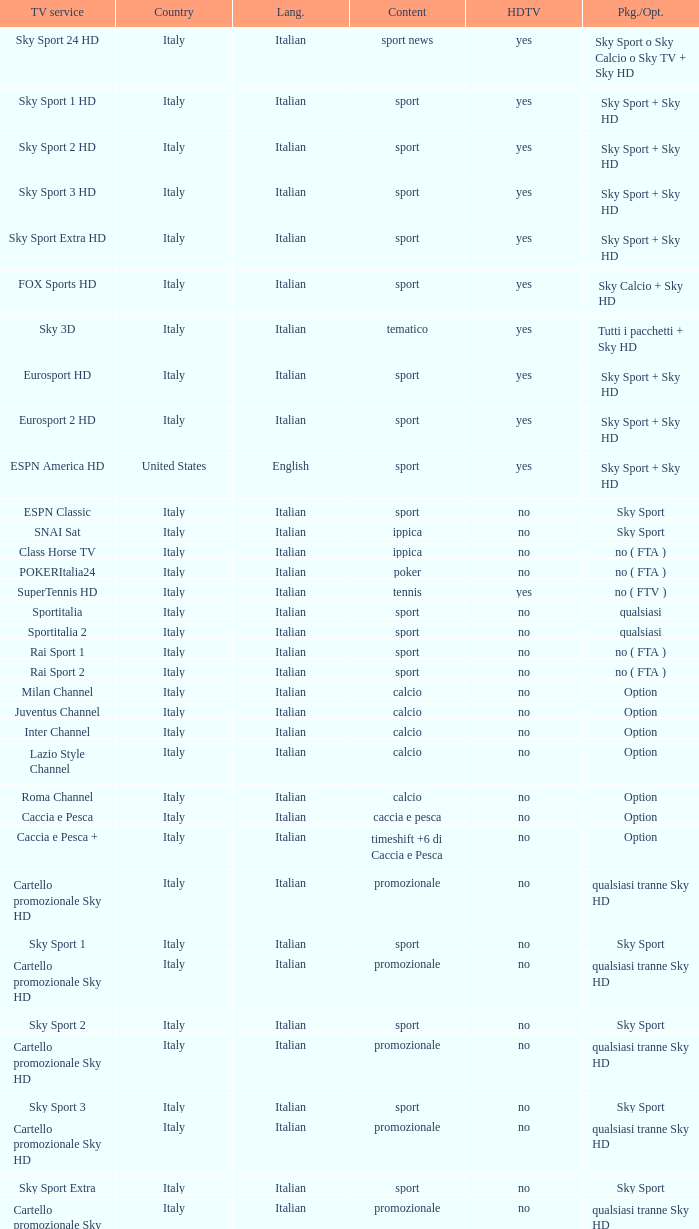What is Country, when Television Service is Eurosport 2? Italy. 